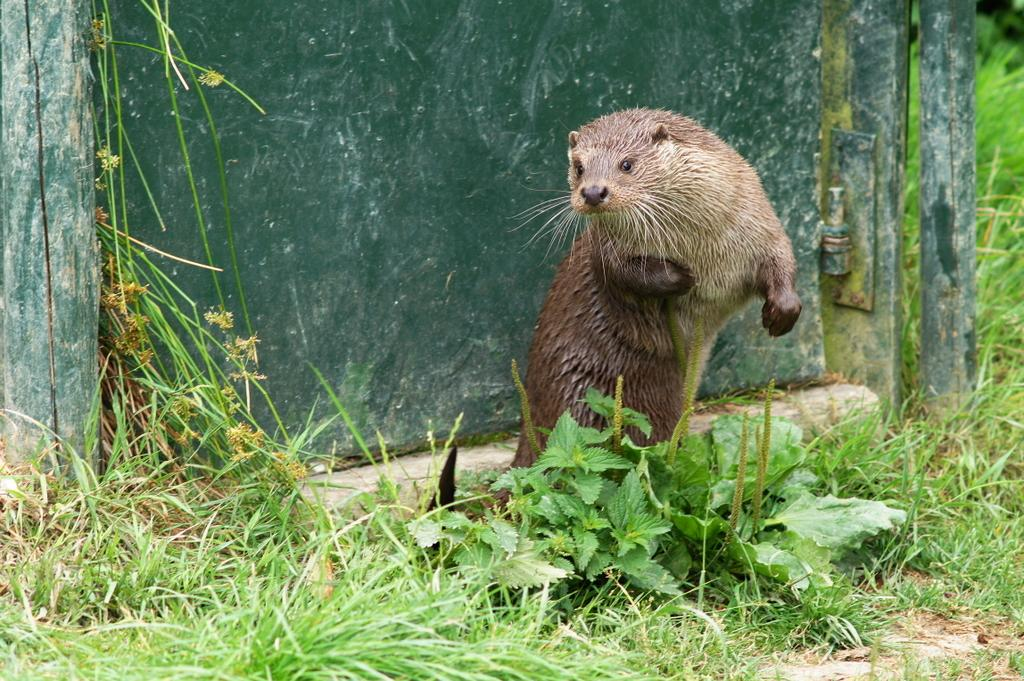What type of animal can be seen on the ground in the image? The image does not specify the type of animal, but there is an animal on the ground. What type of vegetation is visible in the image? There is grass and plants visible in the image. What type of structures can be seen in the image? There are wooden poles and a wall visible in the image. What type of wood is the animal using to build its nest in the image? There is no wood or nest visible in the image; it only shows an animal on the ground, grass, plants, wooden poles, and a wall. What word is written on the wall in the image? There is no word visible on the wall in the image. How many eggs can be seen in the image? There are no eggs present in the image. 